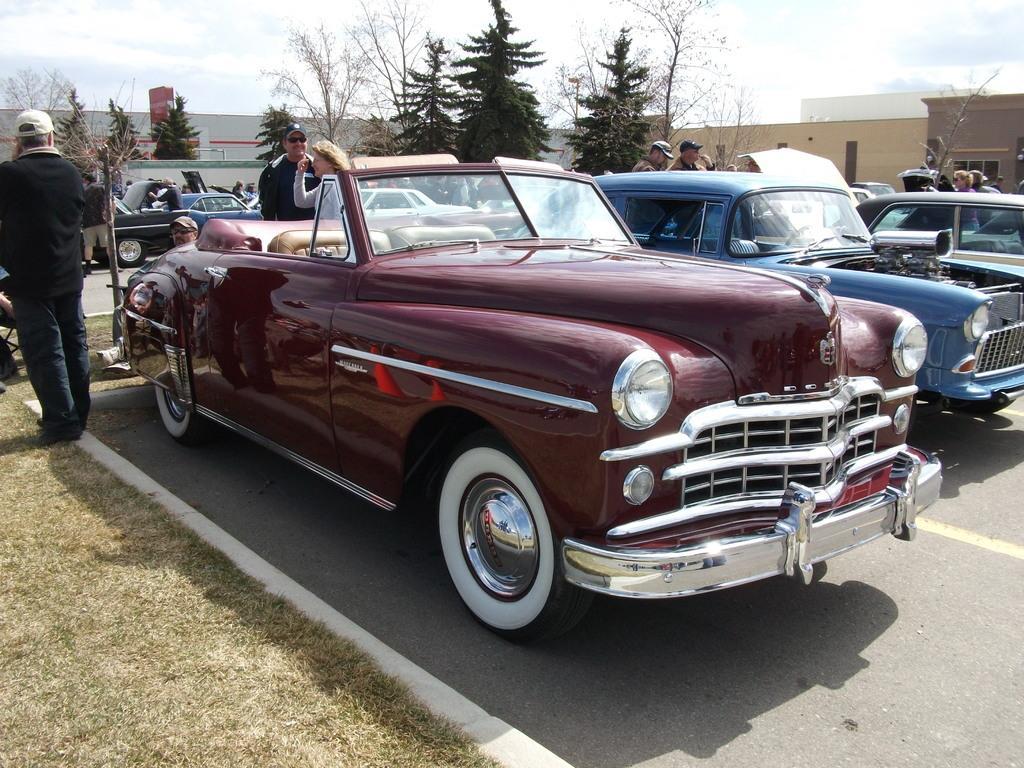Could you give a brief overview of what you see in this image? In the image we can see there are many vehicles of different colors. There are even people wearing clothes, we can even see trees, grass and the cloudy sky. We can even see the road and the buildings. 